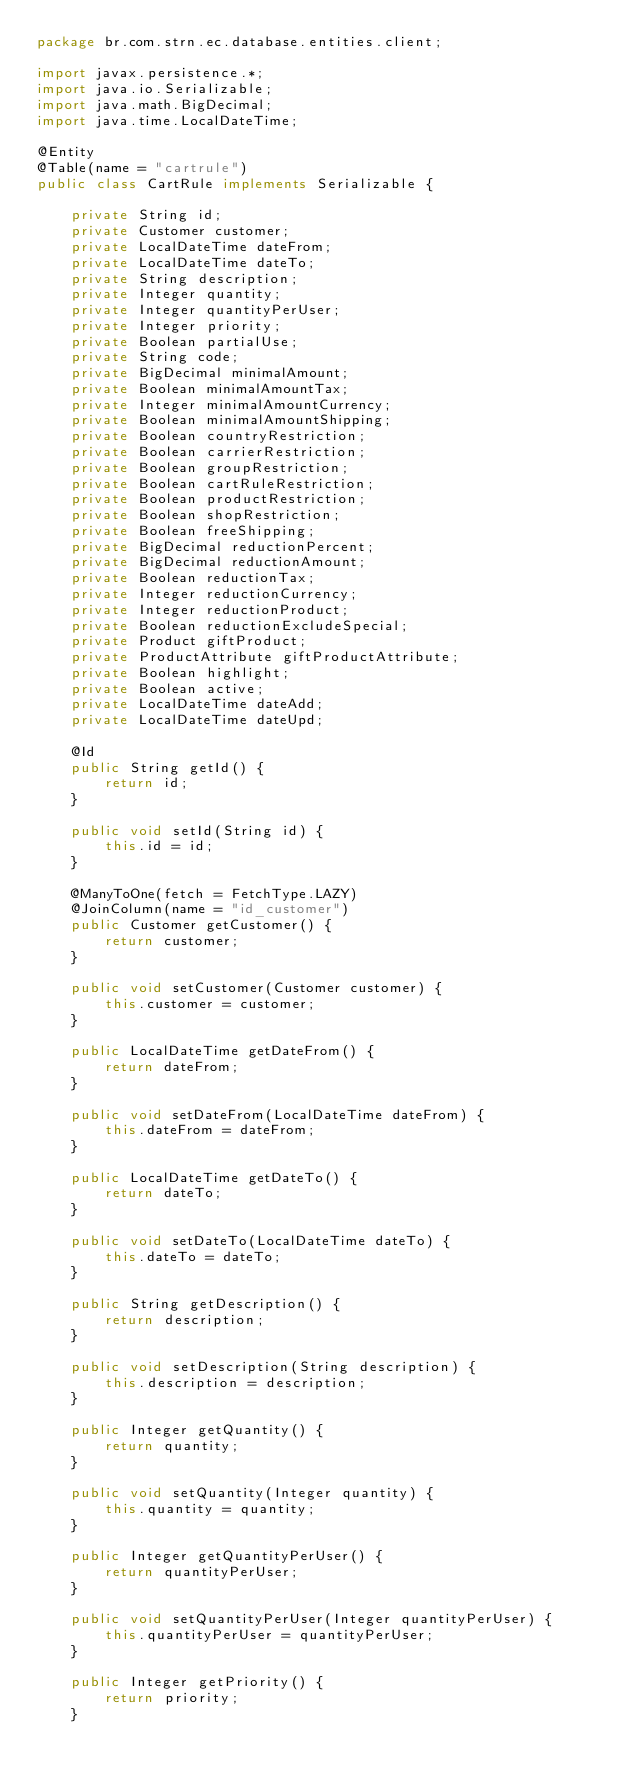<code> <loc_0><loc_0><loc_500><loc_500><_Java_>package br.com.strn.ec.database.entities.client;

import javax.persistence.*;
import java.io.Serializable;
import java.math.BigDecimal;
import java.time.LocalDateTime;

@Entity
@Table(name = "cartrule")
public class CartRule implements Serializable {

    private String id;
    private Customer customer;
    private LocalDateTime dateFrom;
    private LocalDateTime dateTo;
    private String description;
    private Integer quantity;
    private Integer quantityPerUser;
    private Integer priority;
    private Boolean partialUse;
    private String code;
    private BigDecimal minimalAmount;
    private Boolean minimalAmountTax;
    private Integer minimalAmountCurrency;
    private Boolean minimalAmountShipping;
    private Boolean countryRestriction;
    private Boolean carrierRestriction;
    private Boolean groupRestriction;
    private Boolean cartRuleRestriction;
    private Boolean productRestriction;
    private Boolean shopRestriction;
    private Boolean freeShipping;
    private BigDecimal reductionPercent;
    private BigDecimal reductionAmount;
    private Boolean reductionTax;
    private Integer reductionCurrency;
    private Integer reductionProduct;
    private Boolean reductionExcludeSpecial;
    private Product giftProduct;
    private ProductAttribute giftProductAttribute;
    private Boolean highlight;
    private Boolean active;
    private LocalDateTime dateAdd;
    private LocalDateTime dateUpd;

    @Id
    public String getId() {
        return id;
    }

    public void setId(String id) {
        this.id = id;
    }

    @ManyToOne(fetch = FetchType.LAZY)
    @JoinColumn(name = "id_customer")
    public Customer getCustomer() {
        return customer;
    }

    public void setCustomer(Customer customer) {
        this.customer = customer;
    }

    public LocalDateTime getDateFrom() {
        return dateFrom;
    }

    public void setDateFrom(LocalDateTime dateFrom) {
        this.dateFrom = dateFrom;
    }

    public LocalDateTime getDateTo() {
        return dateTo;
    }

    public void setDateTo(LocalDateTime dateTo) {
        this.dateTo = dateTo;
    }

    public String getDescription() {
        return description;
    }

    public void setDescription(String description) {
        this.description = description;
    }

    public Integer getQuantity() {
        return quantity;
    }

    public void setQuantity(Integer quantity) {
        this.quantity = quantity;
    }

    public Integer getQuantityPerUser() {
        return quantityPerUser;
    }

    public void setQuantityPerUser(Integer quantityPerUser) {
        this.quantityPerUser = quantityPerUser;
    }

    public Integer getPriority() {
        return priority;
    }
</code> 